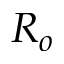<formula> <loc_0><loc_0><loc_500><loc_500>R _ { o }</formula> 